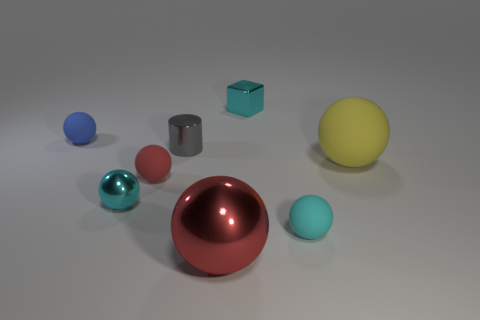Subtract all small metal balls. How many balls are left? 5 Subtract all gray cubes. How many red spheres are left? 2 Subtract all blue balls. How many balls are left? 5 Subtract 4 spheres. How many spheres are left? 2 Add 1 blue matte spheres. How many objects exist? 9 Subtract all cylinders. How many objects are left? 7 Subtract all purple cylinders. Subtract all cyan blocks. How many cylinders are left? 1 Subtract all tiny metallic cubes. Subtract all blue spheres. How many objects are left? 6 Add 2 big yellow matte objects. How many big yellow matte objects are left? 3 Add 7 purple matte cubes. How many purple matte cubes exist? 7 